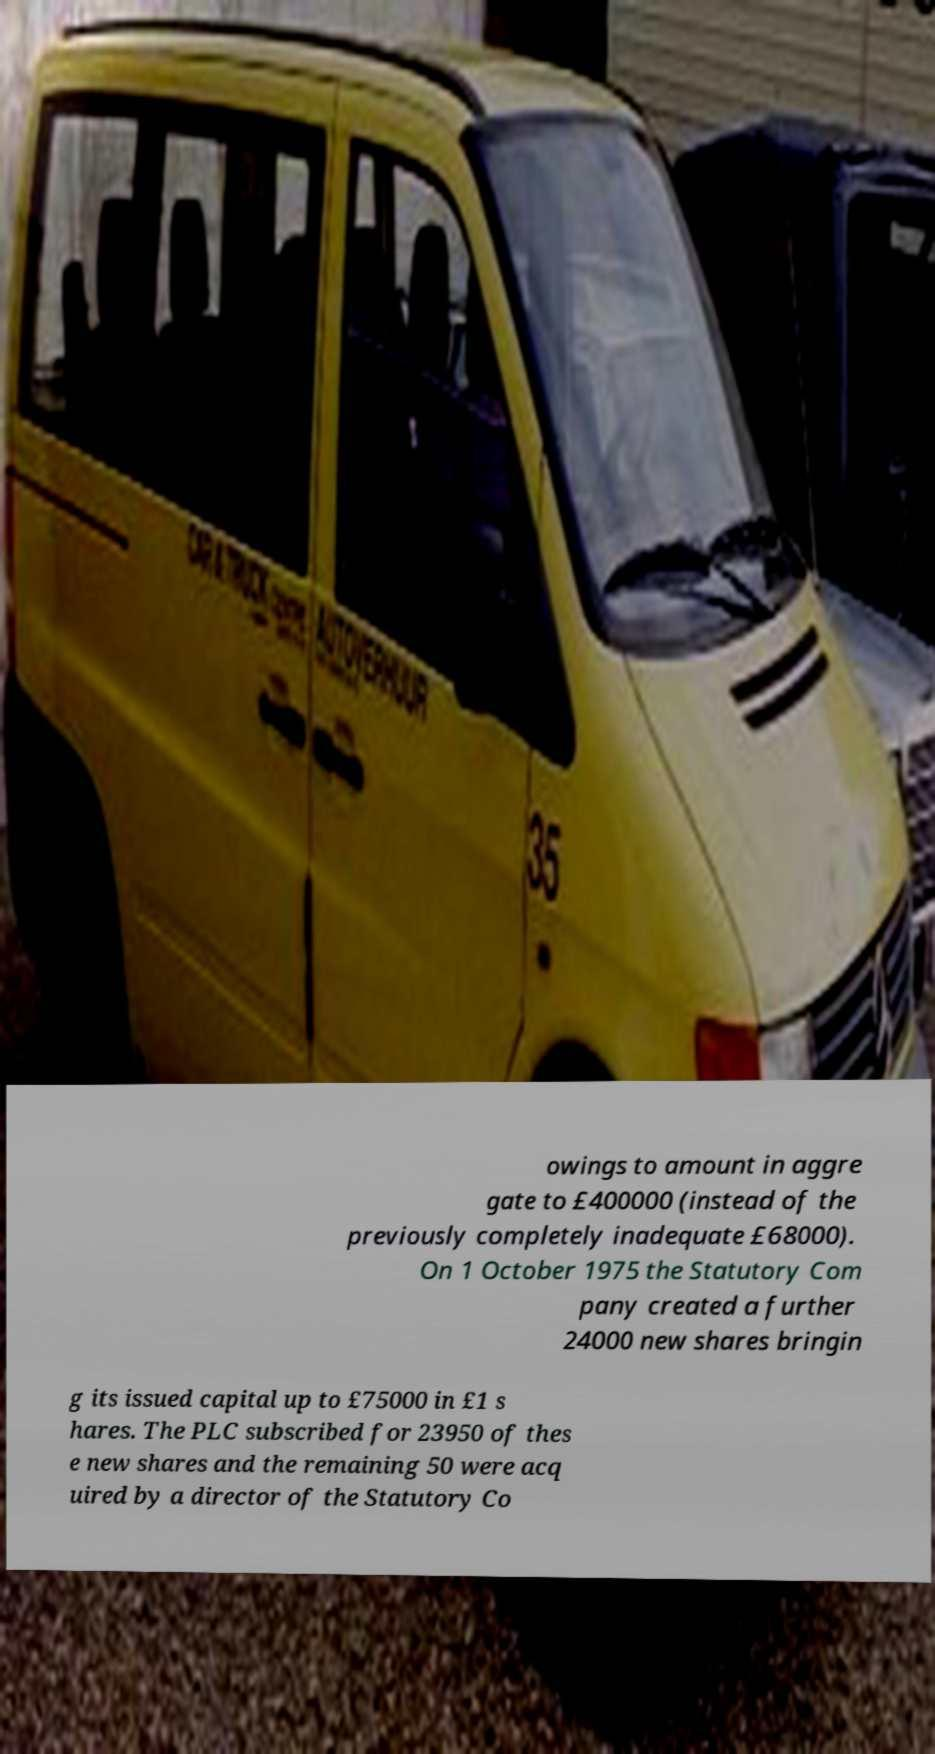I need the written content from this picture converted into text. Can you do that? owings to amount in aggre gate to £400000 (instead of the previously completely inadequate £68000). On 1 October 1975 the Statutory Com pany created a further 24000 new shares bringin g its issued capital up to £75000 in £1 s hares. The PLC subscribed for 23950 of thes e new shares and the remaining 50 were acq uired by a director of the Statutory Co 